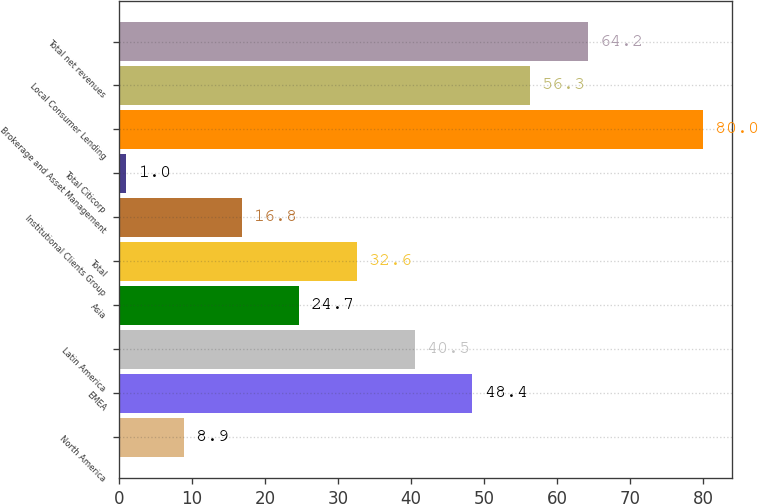<chart> <loc_0><loc_0><loc_500><loc_500><bar_chart><fcel>North America<fcel>EMEA<fcel>Latin America<fcel>Asia<fcel>Total<fcel>Institutional Clients Group<fcel>Total Citicorp<fcel>Brokerage and Asset Management<fcel>Local Consumer Lending<fcel>Total net revenues<nl><fcel>8.9<fcel>48.4<fcel>40.5<fcel>24.7<fcel>32.6<fcel>16.8<fcel>1<fcel>80<fcel>56.3<fcel>64.2<nl></chart> 